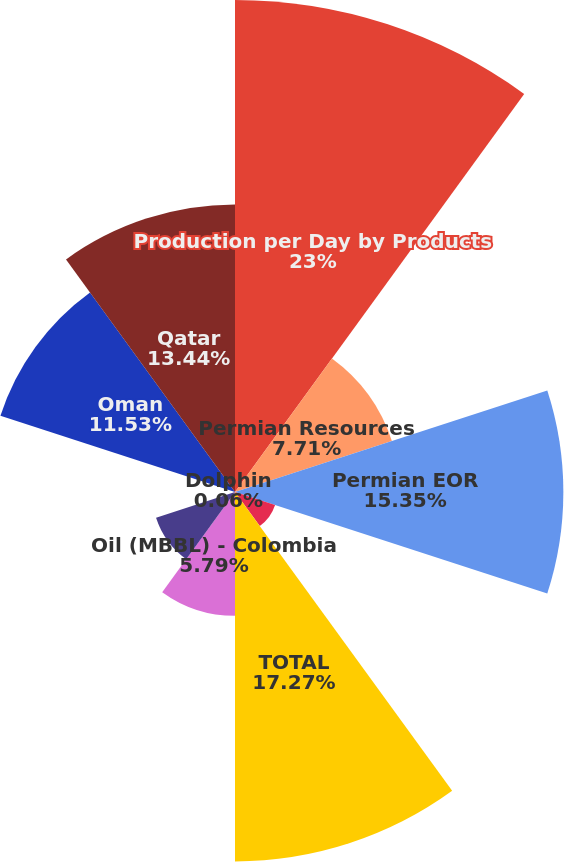Convert chart. <chart><loc_0><loc_0><loc_500><loc_500><pie_chart><fcel>Production per Day by Products<fcel>Permian Resources<fcel>Permian EOR<fcel>Midcontinent and Other<fcel>TOTAL<fcel>Oil (MBBL) - Colombia<fcel>Natural gas (MMCF) - Bolivia<fcel>Dolphin<fcel>Oman<fcel>Qatar<nl><fcel>23.0%<fcel>7.71%<fcel>15.35%<fcel>1.97%<fcel>17.27%<fcel>5.79%<fcel>3.88%<fcel>0.06%<fcel>11.53%<fcel>13.44%<nl></chart> 